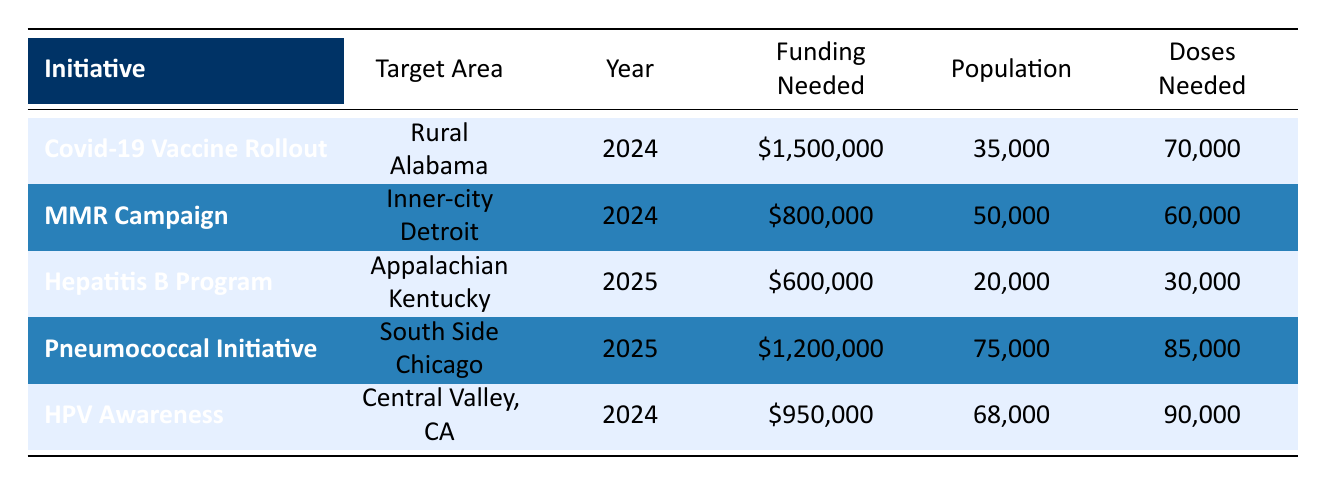What is the projected funding needed for the "Covid-19 Vaccine Rollout" initiative? The table states that the projected funding needed for the "Covid-19 Vaccine Rollout" initiative is \$1,500,000.
Answer: 1,500,000 Which initiative targets "Inner-city Detroit"? The table identifies the "Measles, Mumps, and Rubella (MMR) Campaign" as the initiative targeting "Inner-city Detroit".
Answer: MMR Campaign How many doses are needed for the "HPV Awareness and Vaccination" initiative? According to the table, the "HPV Awareness and Vaccination" initiative requires 90,000 doses.
Answer: 90,000 What is the total projected funding needed for initiatives in 2024? Adding the funding needed for all initiatives in 2024: \$1,500,000 (Covid-19) + \$800,000 (MMR) + \$950,000 (HPV) = \$3,250,000.
Answer: 3,250,000 Which initiative has the highest expected population? The "Pneumococcal Vaccination Initiative" has the highest expected population of 75,000 according to the table.
Answer: Pneumococcal Vaccination Initiative Is the projected funding for the "Hepatitis B Vaccination Program" less than \$1,000,000? Yes, the projected funding for the "Hepatitis B Vaccination Program" is \$600,000, which is less than \$1,000,000.
Answer: Yes What is the average projected funding needed for initiatives in 2025? Calculate the average funding for 2025 initiatives: (600,000 + 1,200,000) / 2 = 900,000.
Answer: 900,000 Which initiative requires the least number of doses? Among the initiatives, the "Hepatitis B Vaccination Program" requires the least number of doses, which is 30,000.
Answer: Hepatitis B Vaccination Program Are all funding sources from government entities? No, the funding sources include private donors and foundations as well, such as "Private Donor Contributions" and "Bill & Melinda Gates Foundation".
Answer: No What is the difference in projected funding needed between the "Pneumococcal Vaccination Initiative" and the "MMR Campaign"? The difference is calculated as \$1,200,000 (Pneumococcal) - \$800,000 (MMR) = \$400,000.
Answer: 400,000 